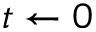Convert formula to latex. <formula><loc_0><loc_0><loc_500><loc_500>t \gets 0</formula> 